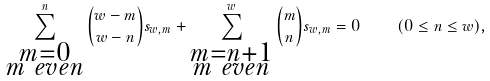<formula> <loc_0><loc_0><loc_500><loc_500>\sum _ { \substack { m = 0 \\ m \ e v e n } } ^ { n } \binom { w - m } { w - n } s _ { w , m } + \sum _ { \substack { m = n + 1 \\ m \ e v e n } } ^ { w } \binom { m } { n } s _ { w , m } = 0 \quad ( 0 \leq n \leq w ) ,</formula> 